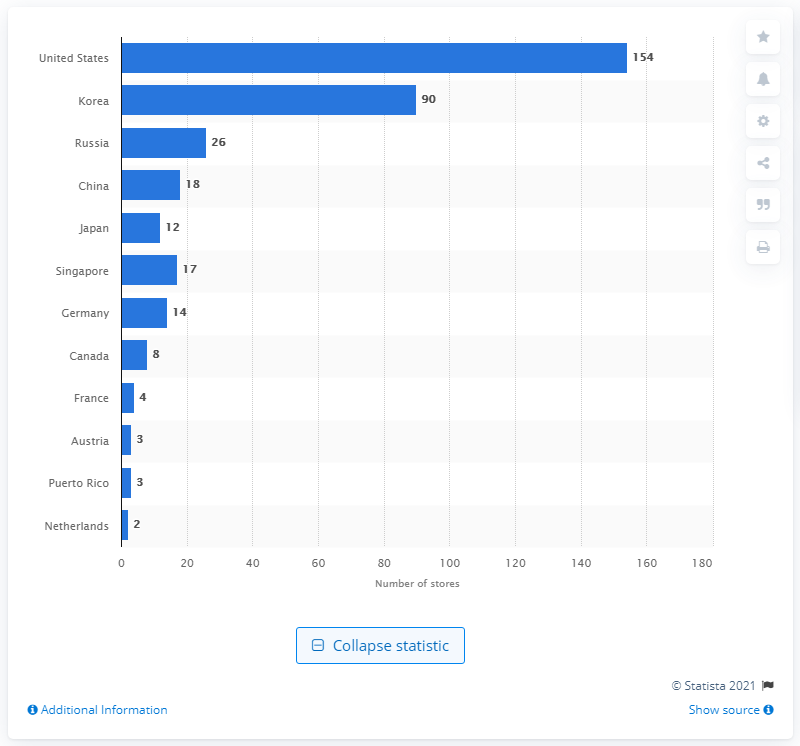Outline some significant characteristics in this image. In 2020, Crocs had 154 retail stores in the United States. 